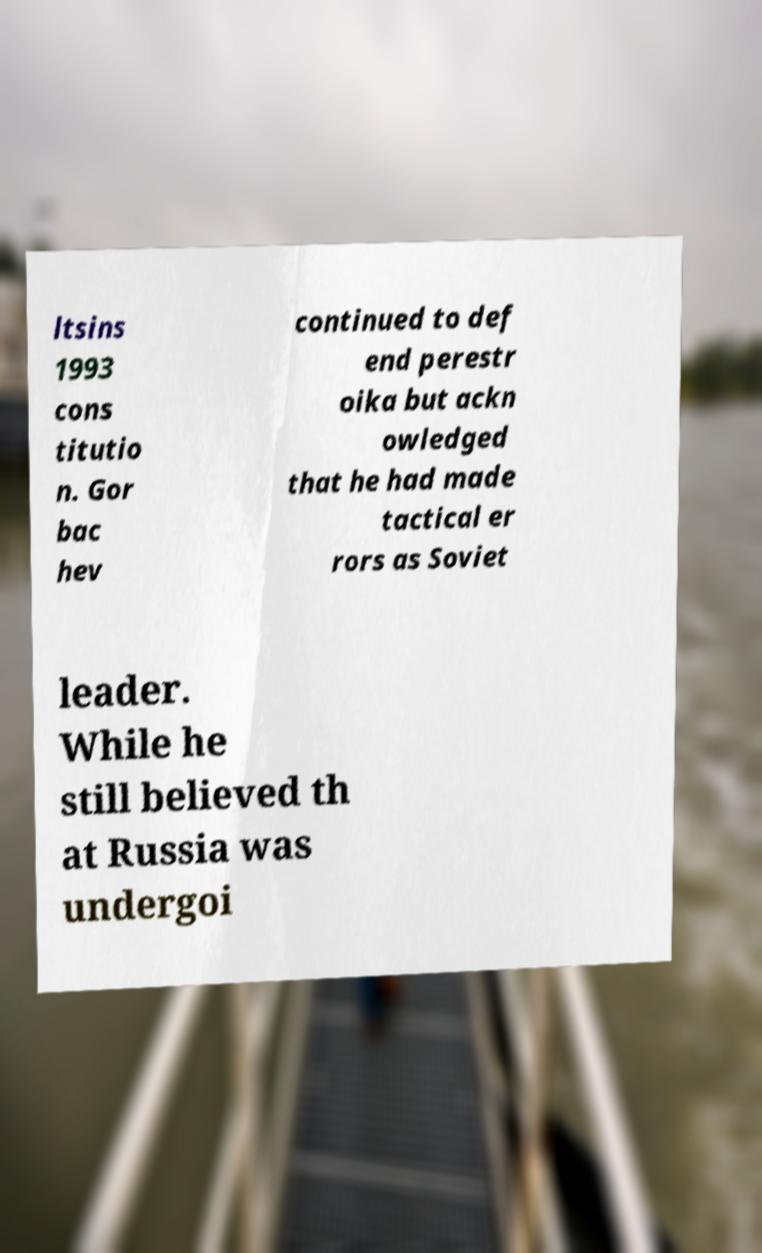Can you read and provide the text displayed in the image?This photo seems to have some interesting text. Can you extract and type it out for me? ltsins 1993 cons titutio n. Gor bac hev continued to def end perestr oika but ackn owledged that he had made tactical er rors as Soviet leader. While he still believed th at Russia was undergoi 